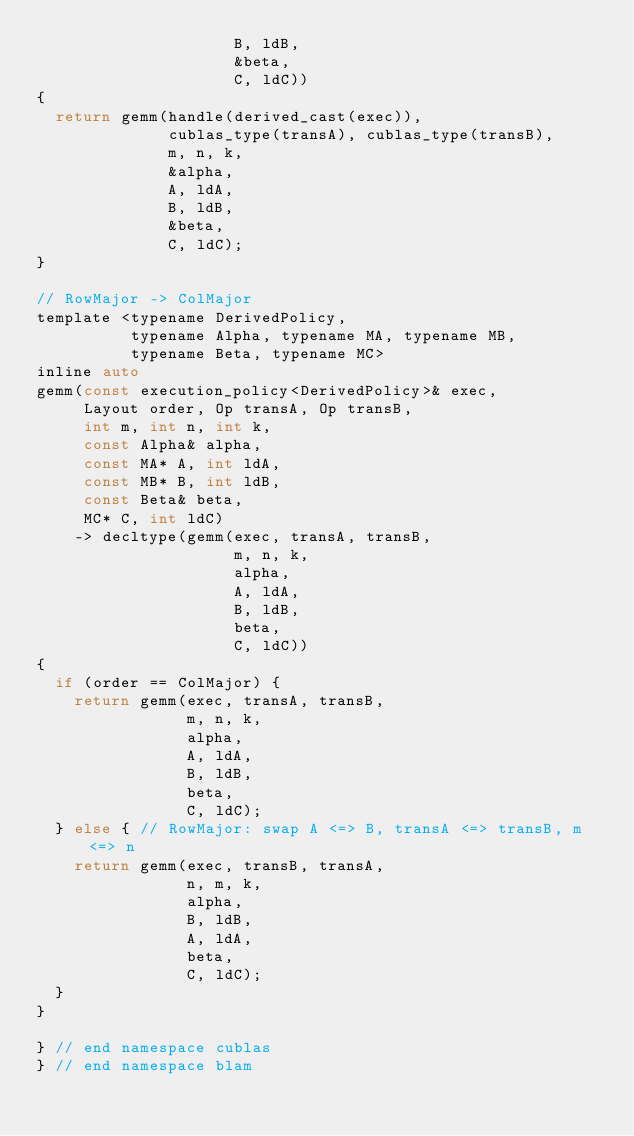<code> <loc_0><loc_0><loc_500><loc_500><_C_>                     B, ldB,
                     &beta,
                     C, ldC))
{
  return gemm(handle(derived_cast(exec)),
              cublas_type(transA), cublas_type(transB),
              m, n, k,
              &alpha,
              A, ldA,
              B, ldB,
              &beta,
              C, ldC);
}

// RowMajor -> ColMajor
template <typename DerivedPolicy,
          typename Alpha, typename MA, typename MB,
          typename Beta, typename MC>
inline auto
gemm(const execution_policy<DerivedPolicy>& exec,
     Layout order, Op transA, Op transB,
     int m, int n, int k,
     const Alpha& alpha,
     const MA* A, int ldA,
     const MB* B, int ldB,
     const Beta& beta,
     MC* C, int ldC)
    -> decltype(gemm(exec, transA, transB,
                     m, n, k,
                     alpha,
                     A, ldA,
                     B, ldB,
                     beta,
                     C, ldC))
{
  if (order == ColMajor) {
    return gemm(exec, transA, transB,
                m, n, k,
                alpha,
                A, ldA,
                B, ldB,
                beta,
                C, ldC);
  } else { // RowMajor: swap A <=> B, transA <=> transB, m <=> n
    return gemm(exec, transB, transA,
                n, m, k,
                alpha,
                B, ldB,
                A, ldA,
                beta,
                C, ldC);
  }
}

} // end namespace cublas
} // end namespace blam
</code> 